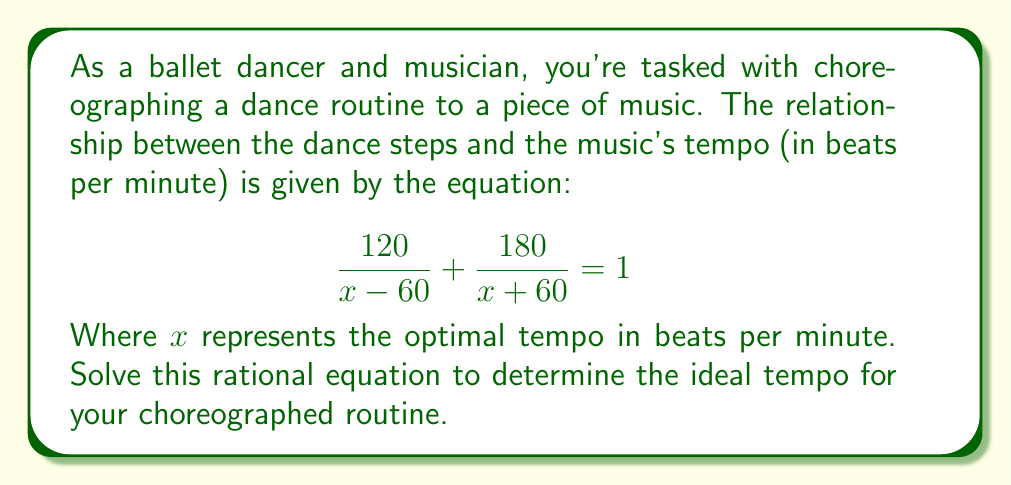Teach me how to tackle this problem. Let's solve this step-by-step:

1) First, we need to find a common denominator. The LCD is $(x-60)(x+60)$.

2) Multiply both sides of the equation by the LCD:

   $$\left(\frac{120}{x - 60} + \frac{180}{x + 60}\right)(x-60)(x+60) = 1(x-60)(x+60)$$

3) Simplify:

   $$120(x+60) + 180(x-60) = (x-60)(x+60)$$

4) Expand the brackets:

   $$120x + 7200 + 180x - 10800 = x^2 - 3600$$

5) Simplify:

   $$300x - 3600 = x^2 - 3600$$

6) Subtract $-3600$ from both sides:

   $$300x = x^2$$

7) Rearrange to standard quadratic form:

   $$x^2 - 300x = 0$$

8) Factor out $x$:

   $$x(x - 300) = 0$$

9) Use the zero product property. Either $x = 0$ or $x - 300 = 0$

10) Solve:
    $x = 0$ or $x = 300$

11) Since tempo cannot be 0 beats per minute, our solution is $x = 300$.
Answer: 300 bpm 